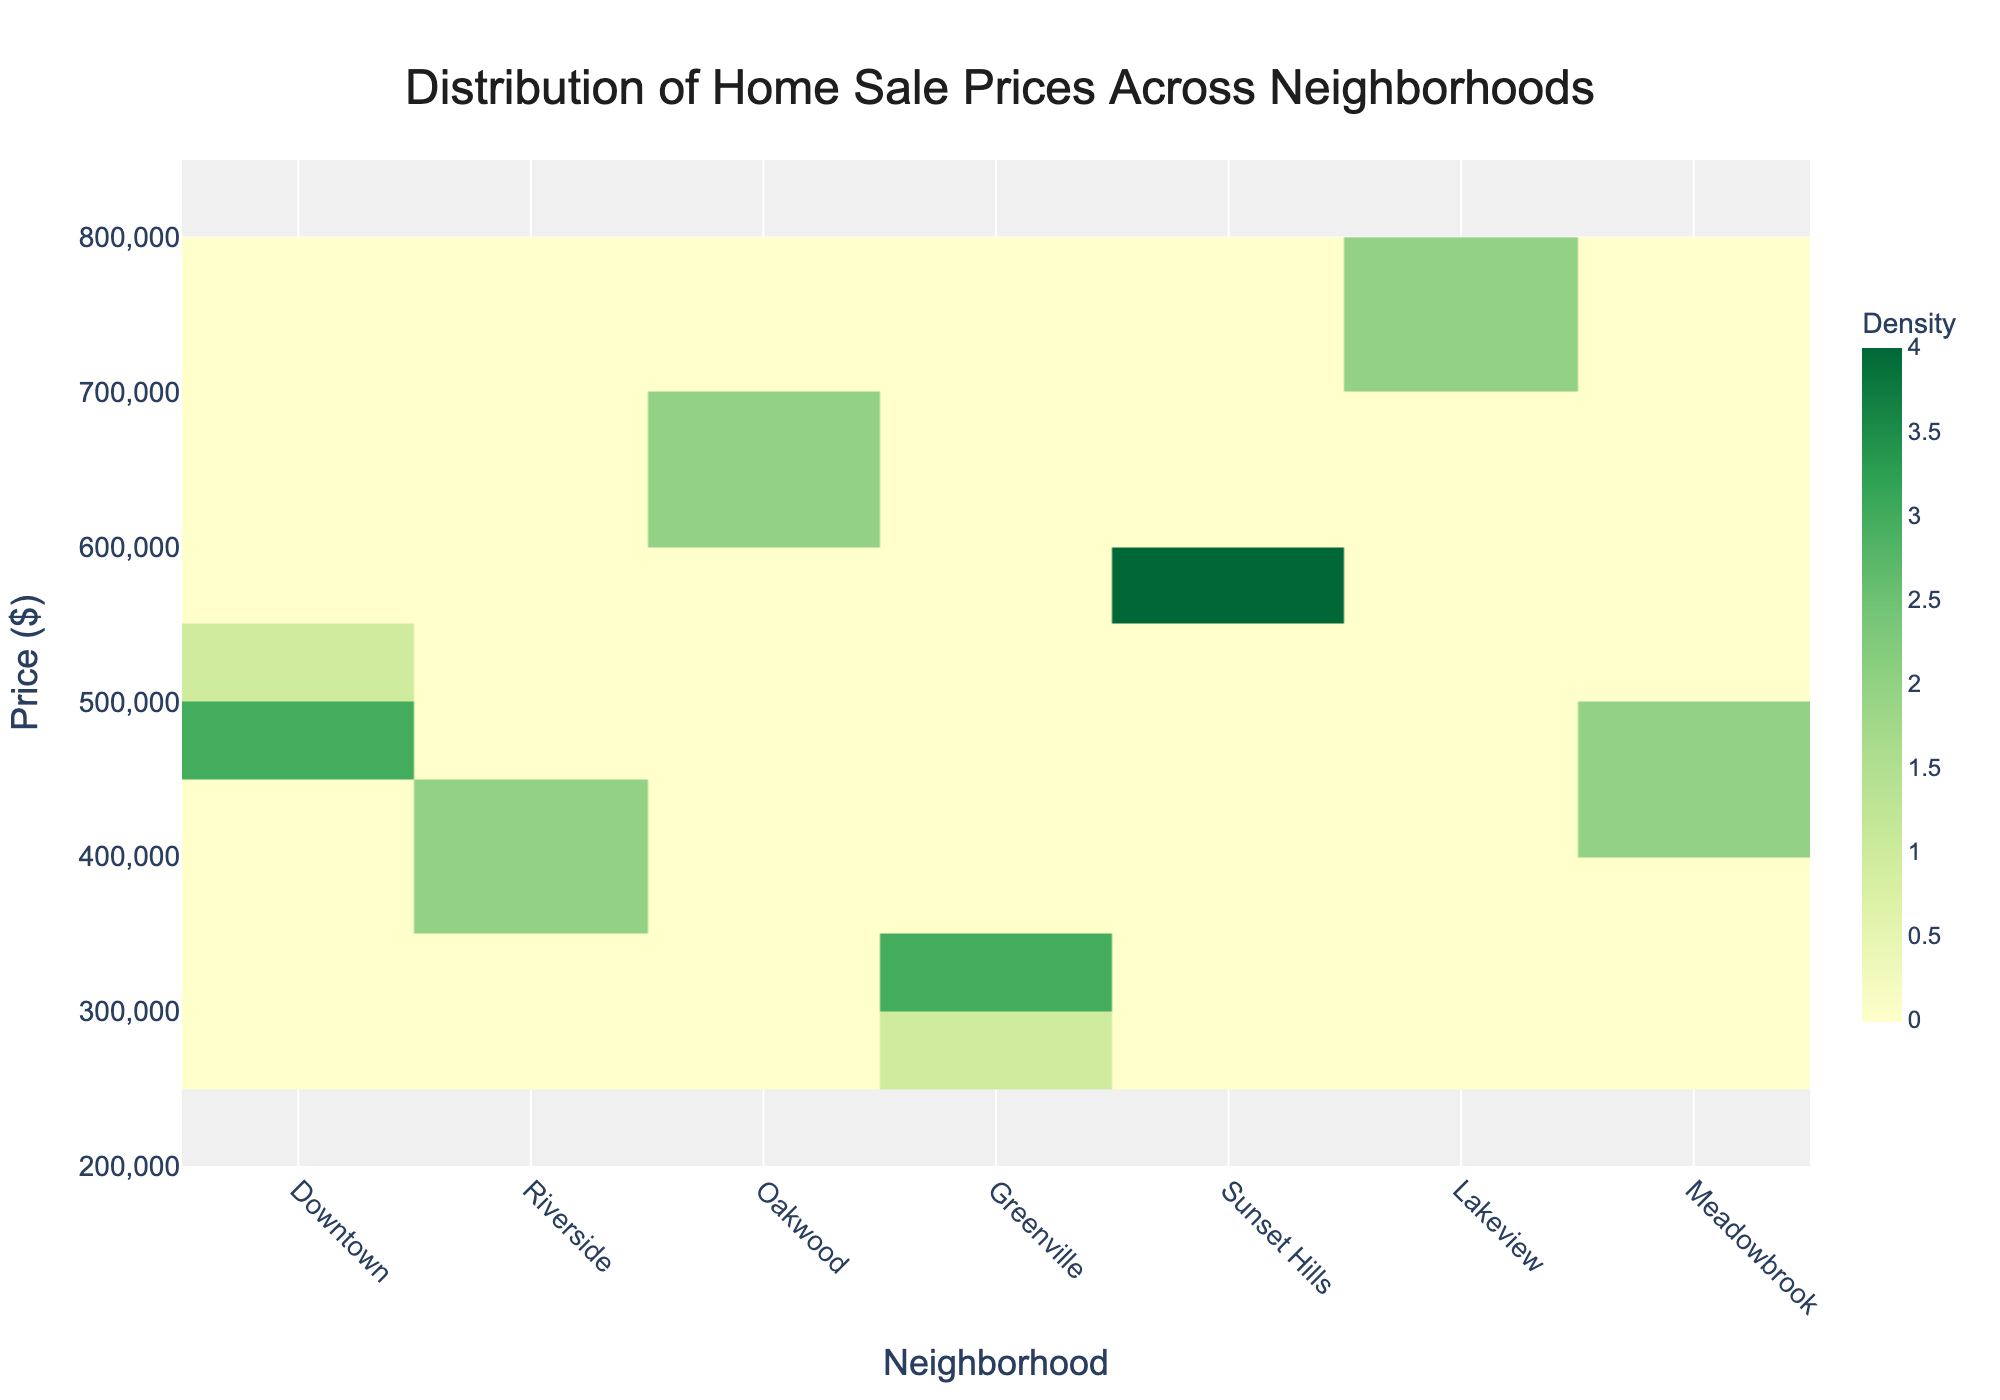What's the title of the plot? The title is displayed at the top of the plot, and it reads "Distribution of Home Sale Prices Across Neighborhoods".
Answer: Distribution of Home Sale Prices Across Neighborhoods What's on the x-axis of the plot? The x-axis label, located at the bottom of the plot, shows "Neighborhood".
Answer: Neighborhood What is the price range displayed on the y-axis? The y-axis, labeled "Price ($)", ranges from $200,000 to $850,000. This range is indicated by the y-axis ticks.
Answer: $200,000 to $850,000 Which neighborhood has the highest concentration of sale prices? By examining the density indicated by the color scale, Downtown shows the highest density of home sale prices as indicated by the darkest color.
Answer: Downtown How do the sale prices in Riverside compare to those in Oakwood? Riverside's prices are clustered around the $380,000 to $425,000 range, which is significantly lower than Oakwood's range of $620,000 to $675,000. This comparison is evident by observing the vertical distribution of data points across the y-axis for each neighborhood.
Answer: Riverside's prices are lower What neighborhood has the widest range of home prices? The neighborhood Lakeview spans the range from approximately $710,000 to $785,000. This range can be observed by the height of the hexbin along the y-axis.
Answer: Lakeview Which neighborhood has the lowest home sale prices? The lowest home prices are in Greenville, fluctuating between $290,000 and $325,000. This can be determined based on the y-axis and the placement of the hexagons in the plot.
Answer: Greenville Do any neighborhoods have overlapping sale price ranges? Yes, Downtown and Meadowbrook show overlapping price ranges as both have data points within the $435,000 to $480,000 range. This observation can be made by comparing the vertical positions of the hexbins within the plot.
Answer: Yes Describe the price trend for homes in Sunset Hills. Sunset Hills has home prices ranging from $550,000 to $595,000, indicating a relatively high price range. The density is moderate compared to Downtown, suggesting a lesser concentration of home sales. This is interpreted from the color gradients and hex positions.
Answer: $550,000 to $595,000 Which neighborhoods have a more concentrated distribution of home prices? Downtown and Riverside have more concentrated distributions, as indicated by the areas with denser color shading. Downtown, in particular, shows the highest concentration, while Riverside has a noticeable but less concentrated density.
Answer: Downtown and Riverside 